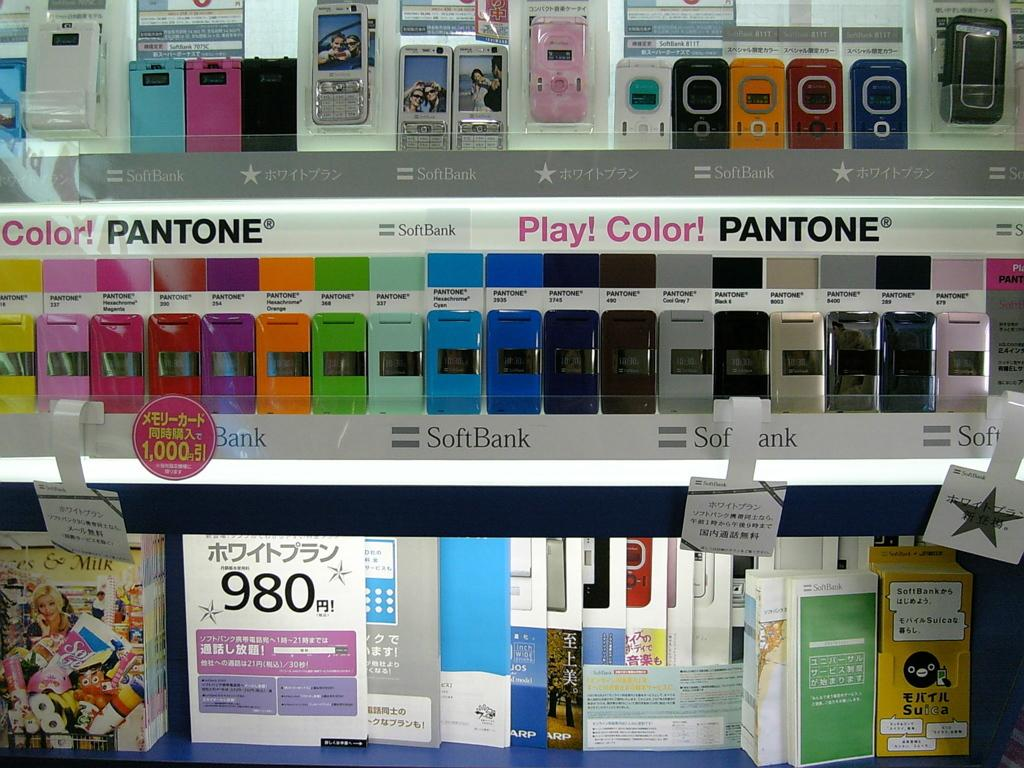<image>
Give a short and clear explanation of the subsequent image. A bunch of cellphones are on two shelves marked with advertisements for Pantone and SoftBank. 